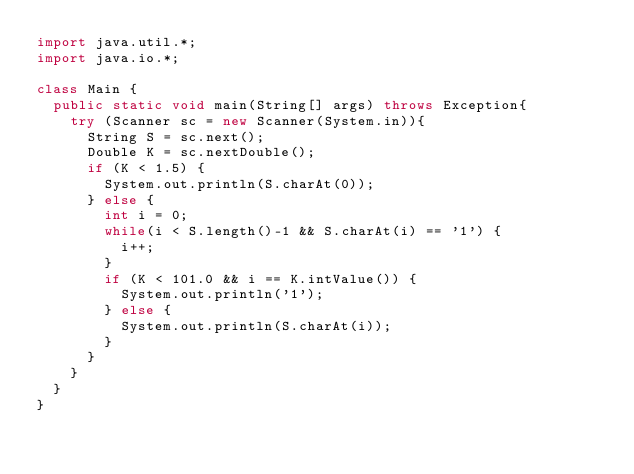Convert code to text. <code><loc_0><loc_0><loc_500><loc_500><_Java_>import java.util.*;
import java.io.*;

class Main {
  public static void main(String[] args) throws Exception{
    try (Scanner sc = new Scanner(System.in)){
      String S = sc.next();
      Double K = sc.nextDouble();
      if (K < 1.5) {
        System.out.println(S.charAt(0));
      } else {
        int i = 0;
        while(i < S.length()-1 && S.charAt(i) == '1') {
          i++;
        }
        if (K < 101.0 && i == K.intValue()) {
          System.out.println('1');
        } else {
          System.out.println(S.charAt(i));
        }
      }
    }
  }
}
</code> 